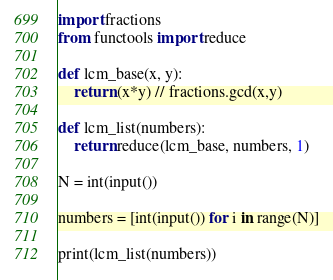<code> <loc_0><loc_0><loc_500><loc_500><_Python_>import fractions
from functools import reduce

def lcm_base(x, y):
    return (x*y) // fractions.gcd(x,y)

def lcm_list(numbers):
    return reduce(lcm_base, numbers, 1)

N = int(input())

numbers = [int(input()) for i in range(N)]

print(lcm_list(numbers))</code> 